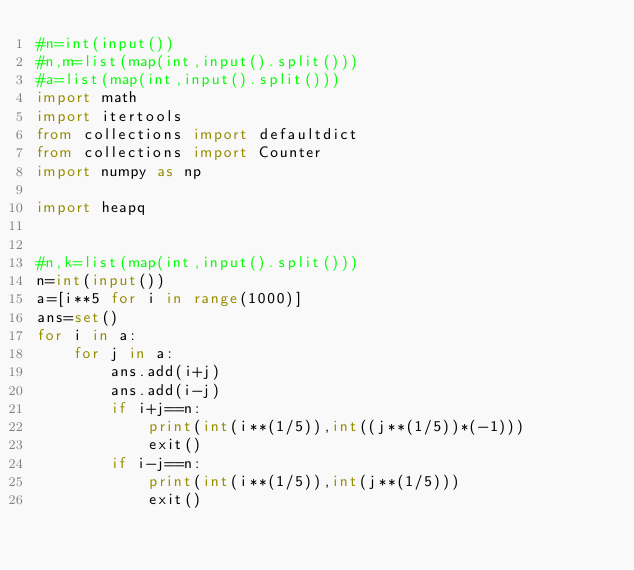<code> <loc_0><loc_0><loc_500><loc_500><_Python_>#n=int(input())
#n,m=list(map(int,input().split()))
#a=list(map(int,input().split()))
import math
import itertools
from collections import defaultdict
from collections import Counter
import numpy as np

import heapq


#n,k=list(map(int,input().split()))
n=int(input())
a=[i**5 for i in range(1000)]
ans=set()
for i in a:
    for j in a:
        ans.add(i+j)
        ans.add(i-j)
        if i+j==n:
            print(int(i**(1/5)),int((j**(1/5))*(-1)))
            exit()
        if i-j==n:
            print(int(i**(1/5)),int(j**(1/5)))
            exit()
</code> 